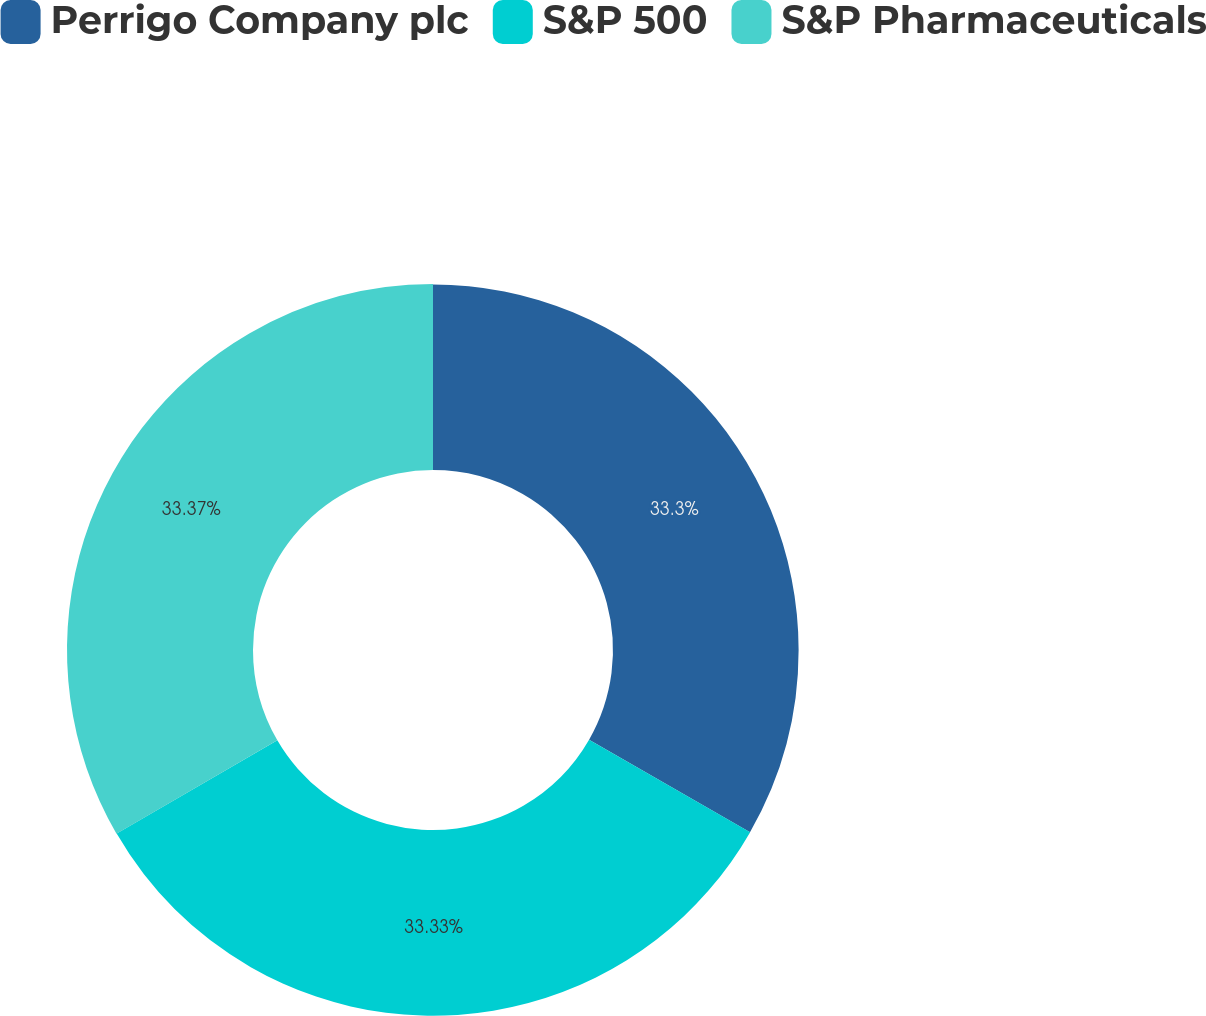Convert chart to OTSL. <chart><loc_0><loc_0><loc_500><loc_500><pie_chart><fcel>Perrigo Company plc<fcel>S&P 500<fcel>S&P Pharmaceuticals<nl><fcel>33.3%<fcel>33.33%<fcel>33.37%<nl></chart> 